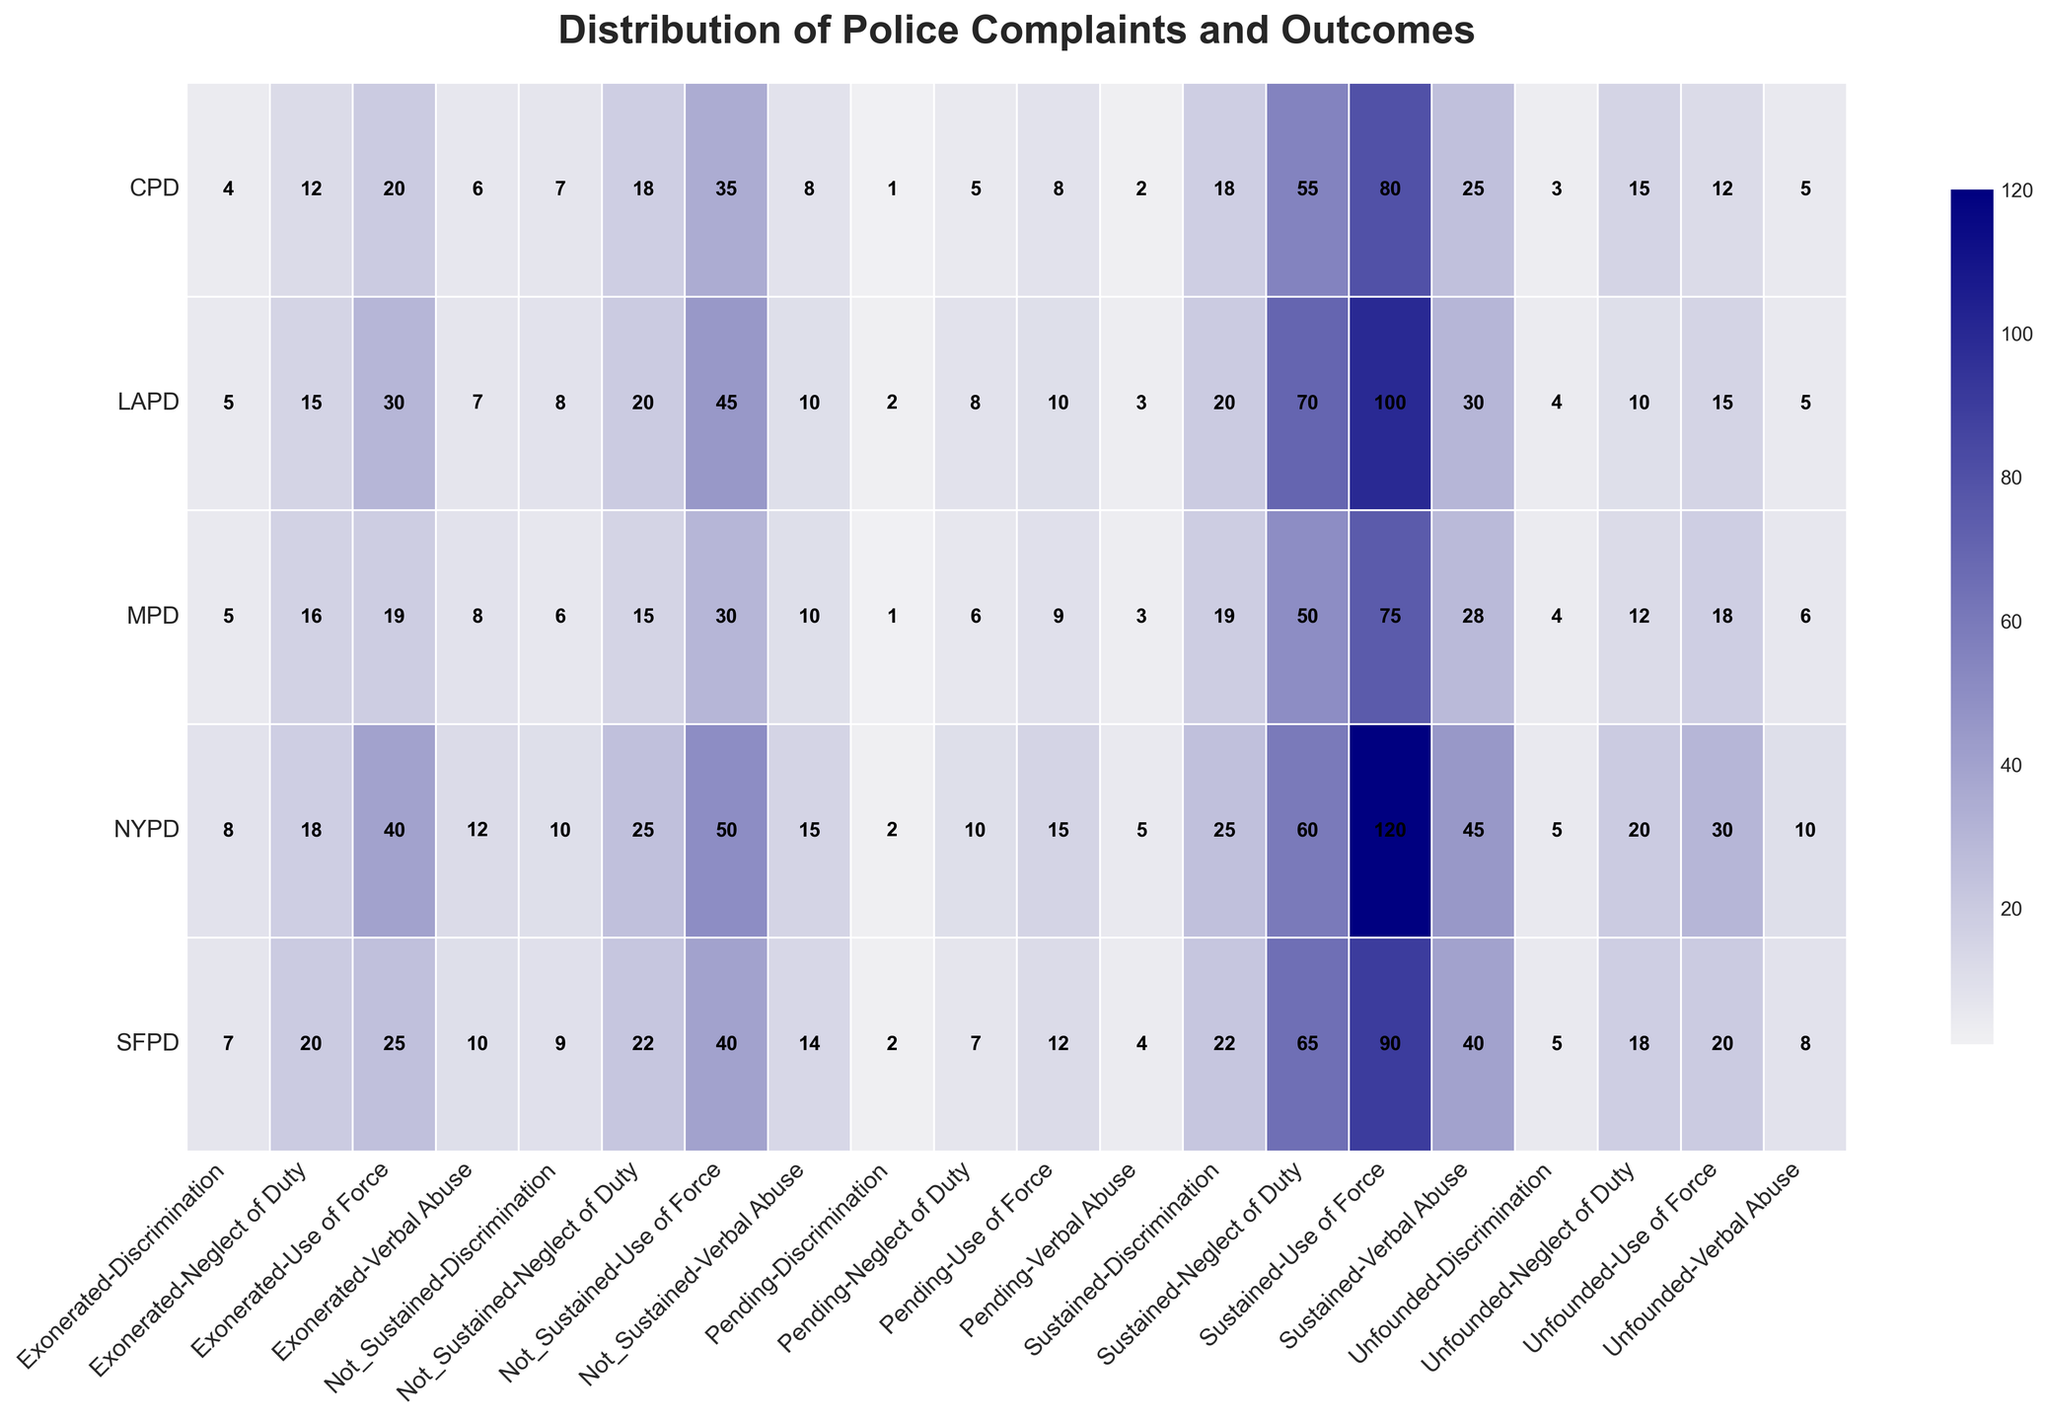What department has the highest number of "Sustained" complaints for "Use of Force"? To find the department with the highest number of sustained complaints for Use of Force, look at the "Sustained" column under the "Use of Force" category for all departments. NYPD has 120, LAPD has 100, CPD has 80, SFPD has 90, and MPD has 75. The highest value is 120 in the NYPD row.
Answer: NYPD Which department has the lowest number of "Unfounded" complaints for "Discrimination"? To identify which department has the lowest number of unfounded complaints for Discrimination, evaluate the "Unfounded" column under the "Discrimination" category for all departments. NYPD has 5, LAPD has 4, CPD has 3, SFPD has 5, and MPD has 4. The lowest value is 3 in the CPD row.
Answer: CPD How many more "Pending" complaints does the NYPD have compared to the MPD for "Neglect of Duty"? Look at the "Pending" complaints for Neglect of Duty in both NYPD and MPD. The NYPD has 10, and MPD has 6. The difference is 10 - 6 = 4.
Answer: 4 Which department has the highest combined total of "Exonerated" and "Pending" complaints for "Verbal Abuse"? Add the values of Exonerated and Pending complaints for Verbal Abuse for each department. NYPD: 12 + 5 = 17, LAPD: 7 + 3 = 10, CPD: 6 + 2 = 8, SFPD: 10 + 4 = 14, MPD: 8 + 3 = 11. The highest combined total is 17 for NYPD.
Answer: NYPD Which complaint type has the highest total number of "Not Sustained" cases across all departments? Sum the "Not Sustained" cases for each complaint type across all departments. Use of Force: 50+45+35+40+30 = 200, Discrimination: 10+8+7+9+6 = 40, Neglect of Duty: 25+20+18+22+15 = 100, Verbal Abuse: 15+10+8+14+10 = 57. "Use of Force" has the highest total with 200.
Answer: Use of Force What is the average number of "Sustained" complaints for "Discrimination" across all departments? Sum the sustained complaints for Discrimination across all departments: 25 + 20 + 18 + 22 + 19 = 104. Then divide by the number of departments, which is 5. The average is 104/5 = 20.8.
Answer: 20.8 Which department has the highest ratio of "Exonerated" to "Sustained" complaints for "Use of Force"? Calculate the ratio of Exonerated to Sustained complaints for Use of Force for each department. NYPD: 40/120 = 0.33, LAPD: 30/100 = 0.3, CPD: 20/80 = 0.25, SFPD: 25/90 = 0.28, MPD: 19/75 = 0.25. The NYPD has the highest ratio of 0.33.
Answer: NYPD Which department has the smallest difference between "Sustained" and "Exonerated" complaints for "Neglect of Duty"? Subtract Exonerated from Sustained complaints for Neglect of Duty for each department. NYPD: 60-18 = 42, LAPD: 70-15 = 55, CPD: 55-12 = 43, SFPD: 65-20 = 45, MPD: 50-16 = 34. The smallest difference is 34 for MPD.
Answer: MPD What is the total number of "Sustained" complaints for "Verbal Abuse" across all police departments? Sum the sustained complaints for Verbal Abuse across all departments: 45 + 30 + 25 + 40 + 28 = 168.
Answer: 168 